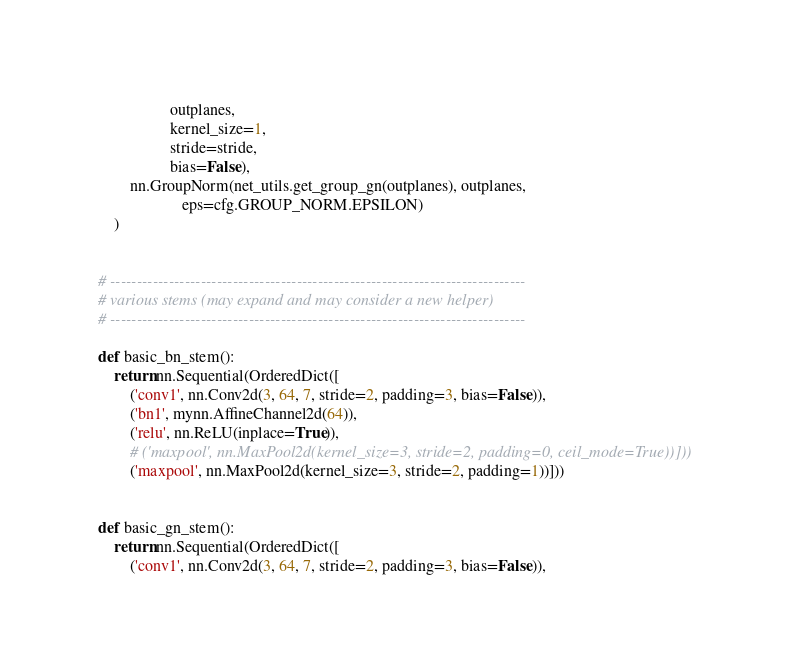Convert code to text. <code><loc_0><loc_0><loc_500><loc_500><_Python_>                  outplanes,
                  kernel_size=1,
                  stride=stride,
                  bias=False),
        nn.GroupNorm(net_utils.get_group_gn(outplanes), outplanes,
                     eps=cfg.GROUP_NORM.EPSILON)
    )


# ------------------------------------------------------------------------------
# various stems (may expand and may consider a new helper)
# ------------------------------------------------------------------------------

def basic_bn_stem():
    return nn.Sequential(OrderedDict([
        ('conv1', nn.Conv2d(3, 64, 7, stride=2, padding=3, bias=False)),
        ('bn1', mynn.AffineChannel2d(64)),
        ('relu', nn.ReLU(inplace=True)),
        # ('maxpool', nn.MaxPool2d(kernel_size=3, stride=2, padding=0, ceil_mode=True))]))
        ('maxpool', nn.MaxPool2d(kernel_size=3, stride=2, padding=1))]))


def basic_gn_stem():
    return nn.Sequential(OrderedDict([
        ('conv1', nn.Conv2d(3, 64, 7, stride=2, padding=3, bias=False)),</code> 